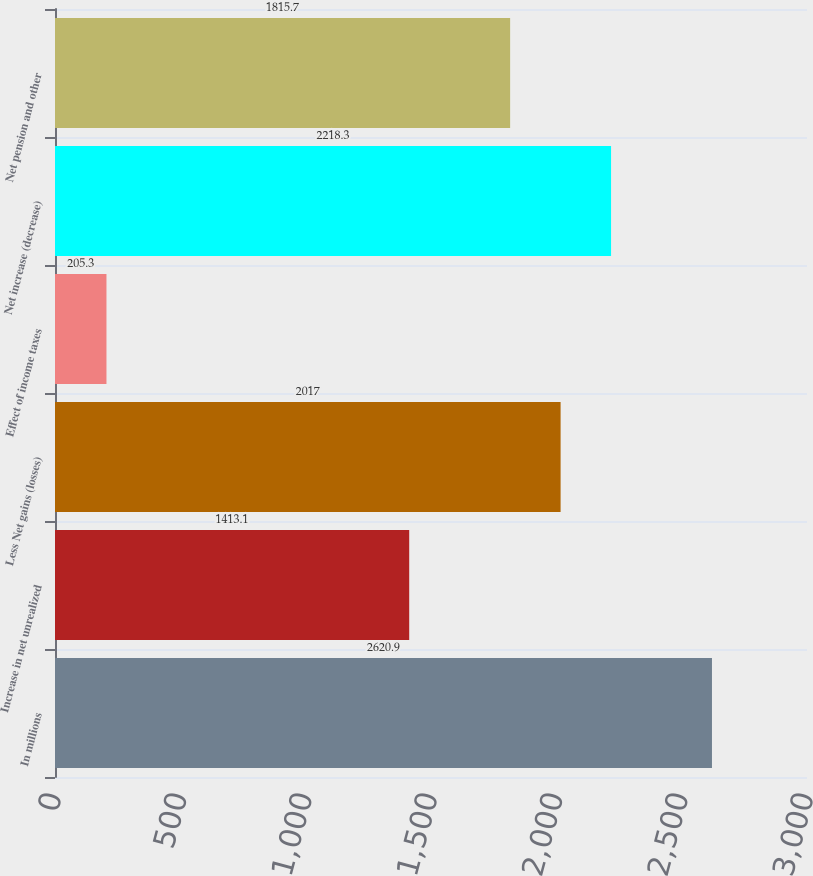Convert chart. <chart><loc_0><loc_0><loc_500><loc_500><bar_chart><fcel>In millions<fcel>Increase in net unrealized<fcel>Less Net gains (losses)<fcel>Effect of income taxes<fcel>Net increase (decrease)<fcel>Net pension and other<nl><fcel>2620.9<fcel>1413.1<fcel>2017<fcel>205.3<fcel>2218.3<fcel>1815.7<nl></chart> 